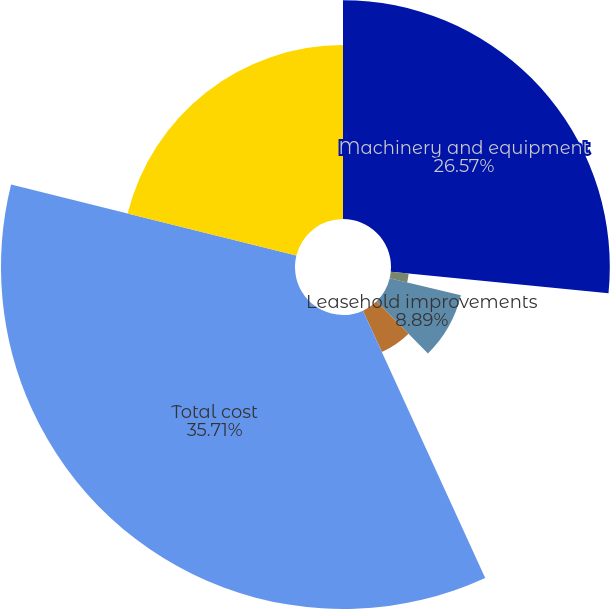Convert chart to OTSL. <chart><loc_0><loc_0><loc_500><loc_500><pie_chart><fcel>Machinery and equipment<fcel>Furniture and fixtures<fcel>Leasehold improvements<fcel>Construction in progress<fcel>Total cost<fcel>Less accumulated depreciation<nl><fcel>26.57%<fcel>2.18%<fcel>8.89%<fcel>5.53%<fcel>35.7%<fcel>21.12%<nl></chart> 